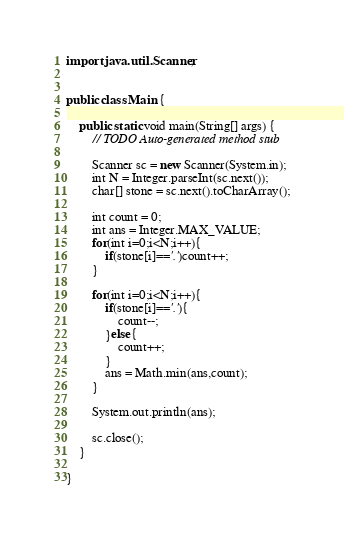<code> <loc_0><loc_0><loc_500><loc_500><_Java_>

import java.util.Scanner;


public class Main {
	
	public static void main(String[] args) {
		// TODO Auto-generated method stub
		
		Scanner sc = new Scanner(System.in);
		int N = Integer.parseInt(sc.next());
		char[] stone = sc.next().toCharArray();
		
		int count = 0;
		int ans = Integer.MAX_VALUE;
		for(int i=0;i<N;i++){
			if(stone[i]=='.')count++;
		}
		
		for(int i=0;i<N;i++){
			if(stone[i]=='.'){
				count--;
			}else{
				count++;
			}
			ans = Math.min(ans,count);
		}

		System.out.println(ans);
		
		sc.close();
	}
	
}
</code> 